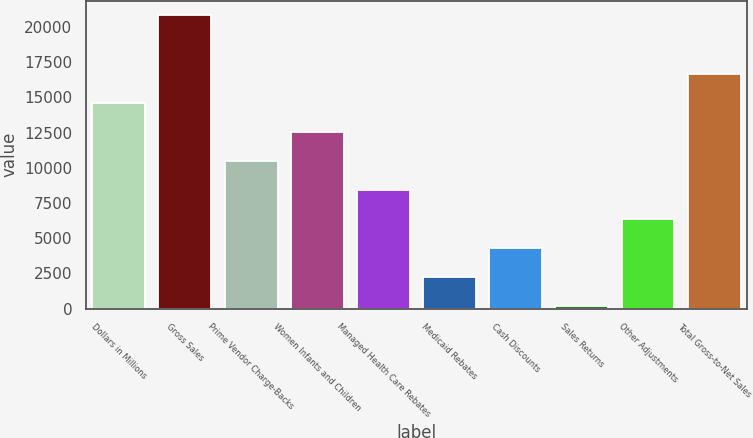Convert chart to OTSL. <chart><loc_0><loc_0><loc_500><loc_500><bar_chart><fcel>Dollars in Millions<fcel>Gross Sales<fcel>Prime Vendor Charge-Backs<fcel>Women Infants and Children<fcel>Managed Health Care Rebates<fcel>Medicaid Rebates<fcel>Cash Discounts<fcel>Sales Returns<fcel>Other Adjustments<fcel>Total Gross-to-Net Sales<nl><fcel>14616.3<fcel>20814<fcel>10484.5<fcel>12550.4<fcel>8418.6<fcel>2220.9<fcel>4286.8<fcel>155<fcel>6352.7<fcel>16682.2<nl></chart> 